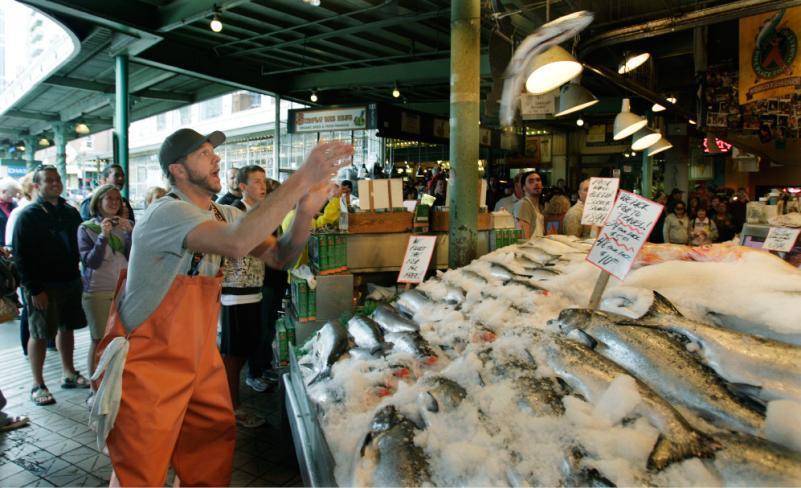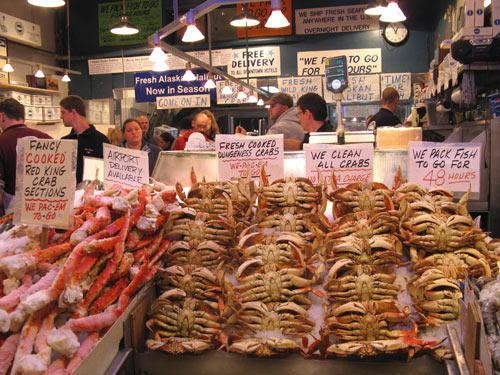The first image is the image on the left, the second image is the image on the right. Evaluate the accuracy of this statement regarding the images: "An image shows a man standing in front of a display of fish with his arms raised to catch a fish coming toward him.". Is it true? Answer yes or no. Yes. The first image is the image on the left, the second image is the image on the right. Analyze the images presented: Is the assertion "In one image, a man near a display of iced fish has his arms outstretched, while a second image shows iced crabs and crab legs for sale." valid? Answer yes or no. Yes. 